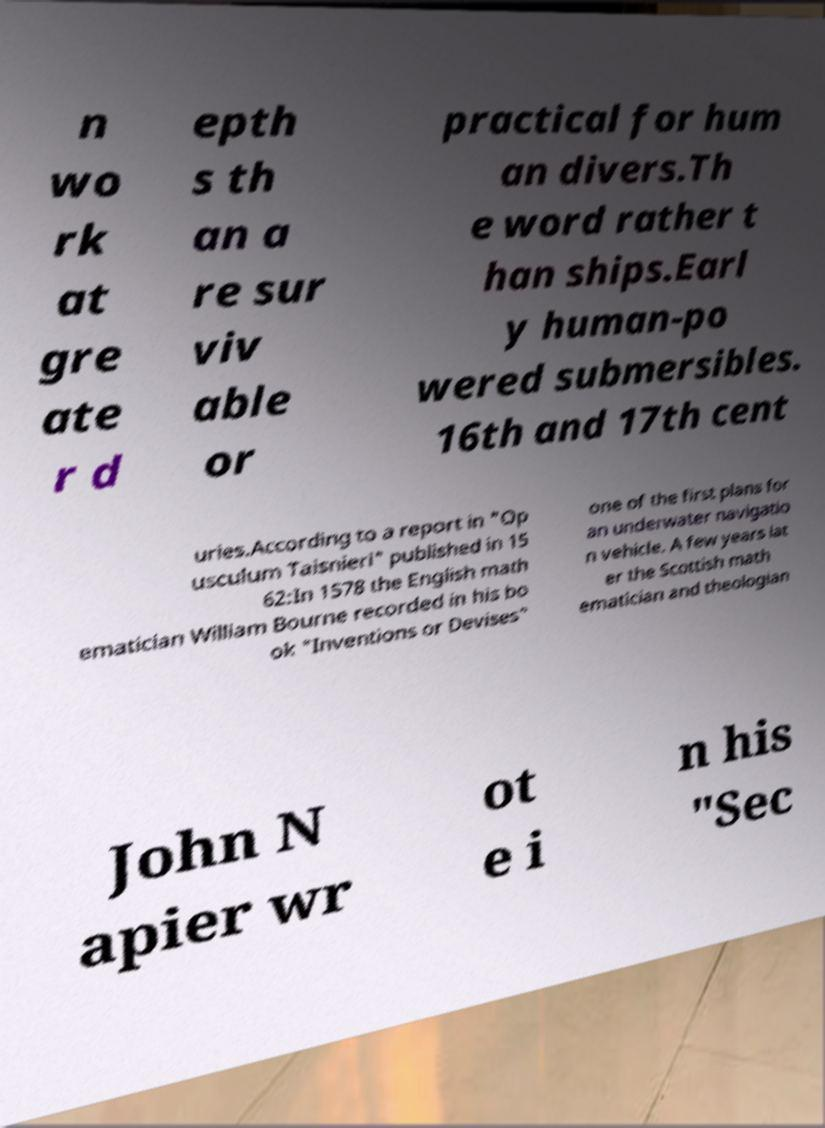What messages or text are displayed in this image? I need them in a readable, typed format. n wo rk at gre ate r d epth s th an a re sur viv able or practical for hum an divers.Th e word rather t han ships.Earl y human-po wered submersibles. 16th and 17th cent uries.According to a report in "Op usculum Taisnieri" published in 15 62:In 1578 the English math ematician William Bourne recorded in his bo ok "Inventions or Devises" one of the first plans for an underwater navigatio n vehicle. A few years lat er the Scottish math ematician and theologian John N apier wr ot e i n his "Sec 